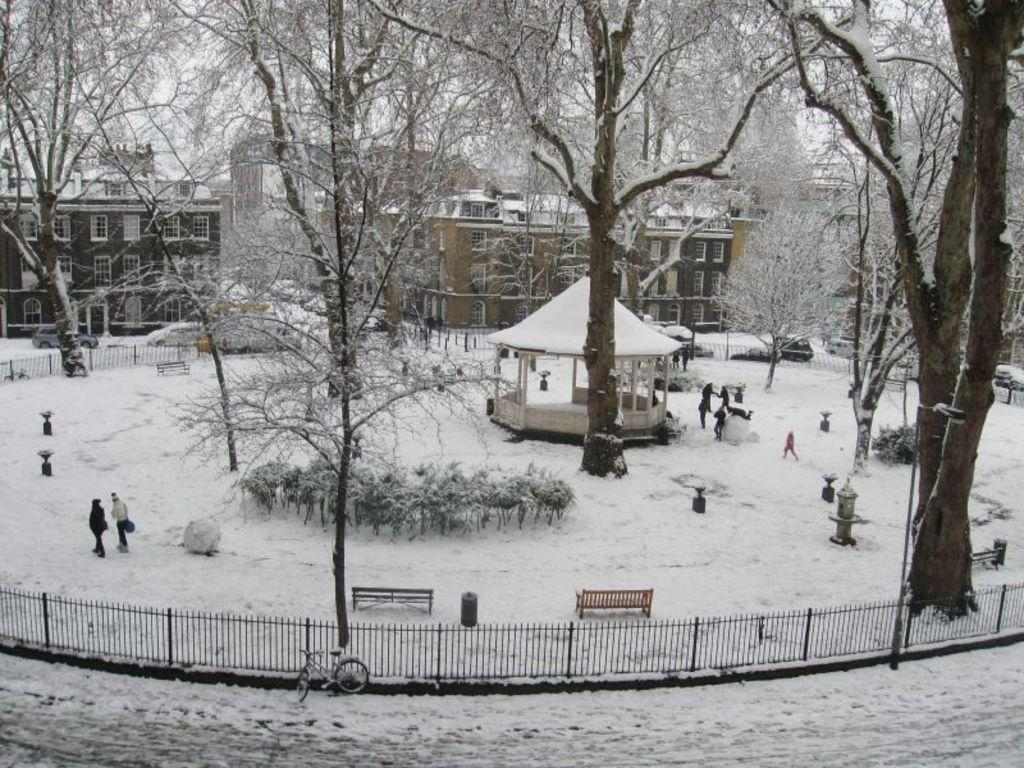What type of barrier can be seen in the image? There is a fence in the image. What is the weather like in the image? There is snow in the image, indicating a cold and likely wintery scene. What mode of transportation is present in the image? There is a bicycle in the image. What type of seating is available in the image? There are benches in the image. Are there any people in the image? Yes, there are people in the image. What can be seen in the background of the image? There are buildings, trees, plants, and the sky visible in the background of the image. What type of collar can be seen on the giants in the image? There are no giants present in the image, so there is no collar to be seen. How do the people in the image answer the questions about the image? The people in the image are not answering any questions about the image, as they are not interacting with the viewer. 